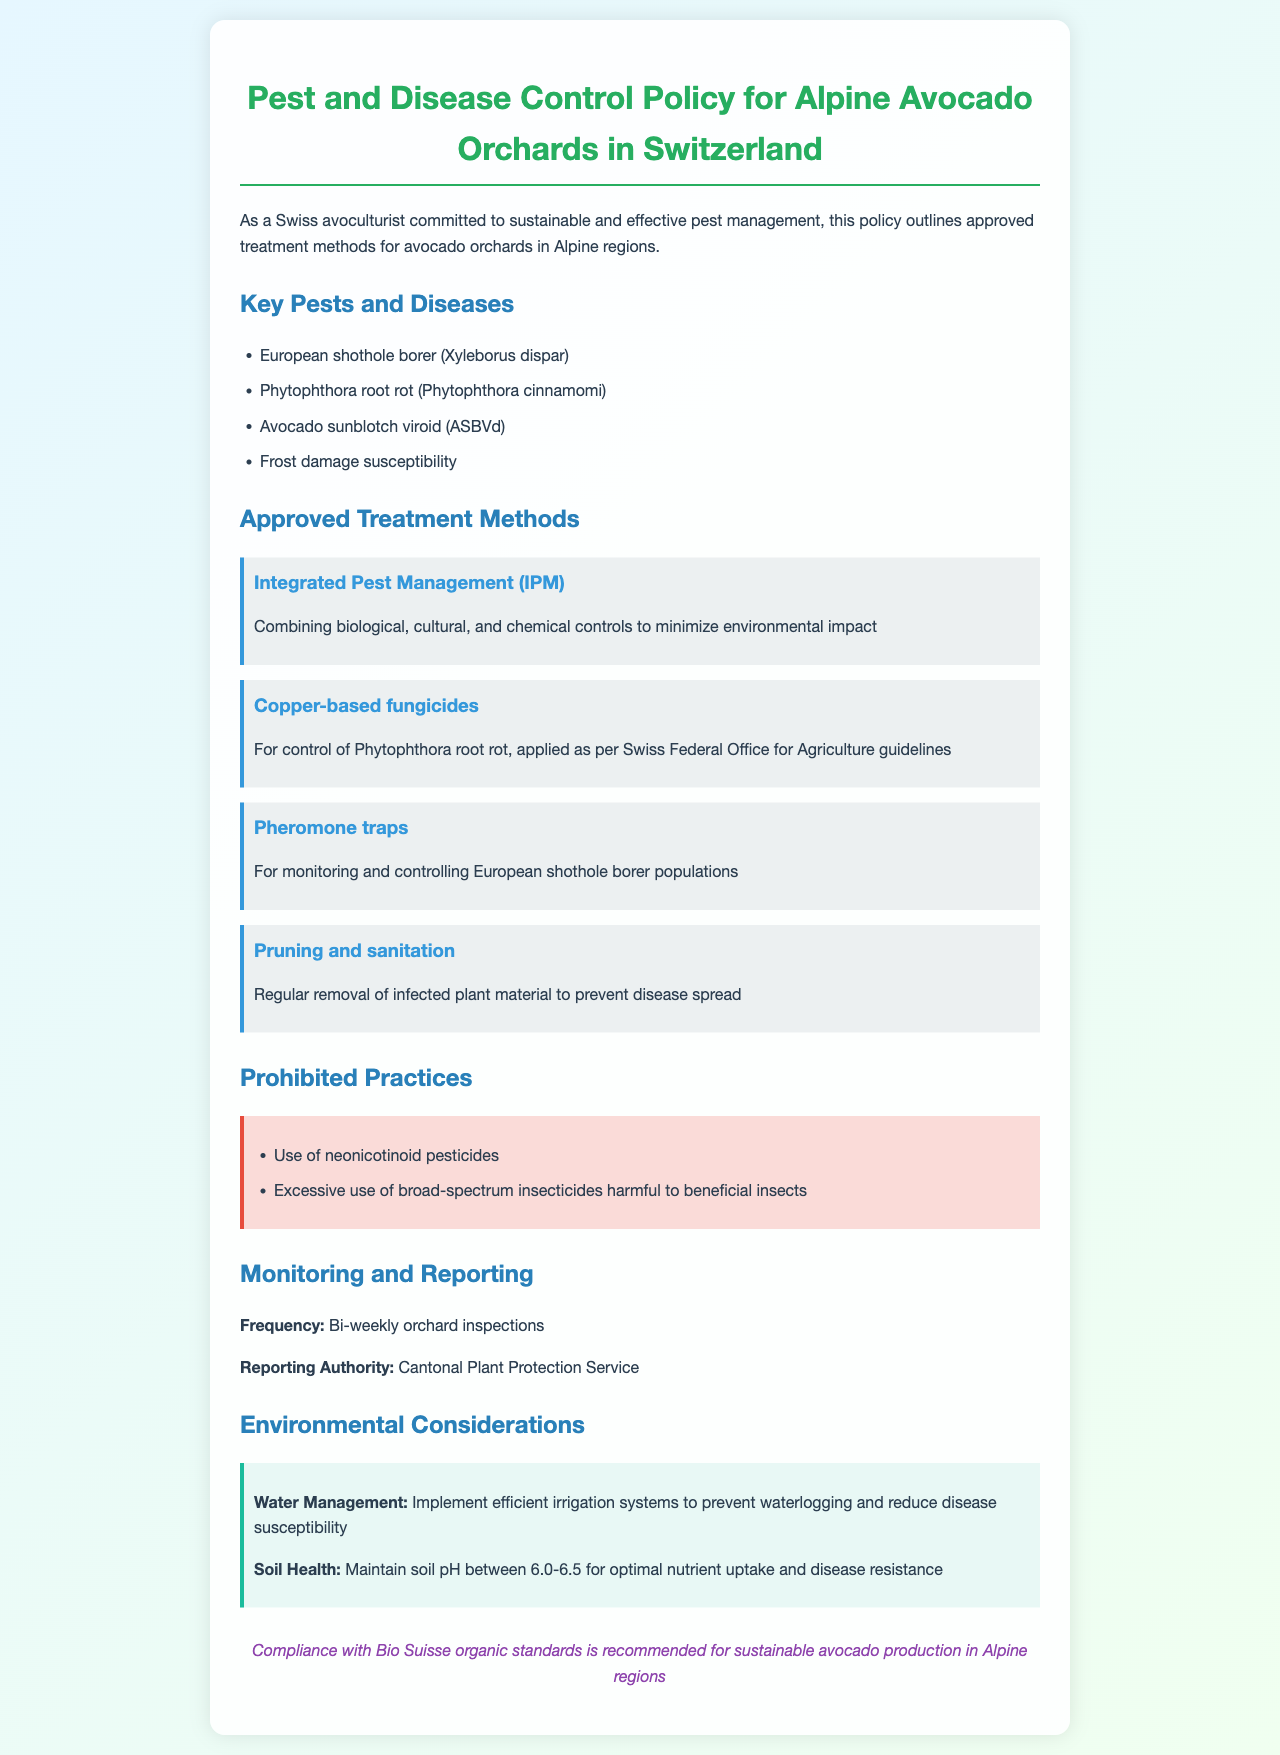what is the title of the document? The title is found in the header section of the document, which introduces the main topic.
Answer: Pest and Disease Control Policy for Alpine Avocado Orchards in Switzerland what is one of the key pests mentioned? The document lists several pests and diseases; referring to the section on key pests is necessary for the answer.
Answer: European shothole borer (Xyleborus dispar) what is the frequency of orchard inspections? The frequency is specified in the Monitoring and Reporting section, detailing the regularity of inspections.
Answer: Bi-weekly which treatment method is used for monitoring shothole borer populations? The document explicitly states specific approved treatment methods, including one specifically aimed at monitoring.
Answer: Pheromone traps what does IPM stand for? The abbreviation IPM is defined in the Approve Treatment Methods section and indicates a specific pest management strategy.
Answer: Integrated Pest Management who is the reporting authority for pest control? The document identifies the authority responsible for reporting, as mentioned under the Monitoring and Reporting section.
Answer: Cantonal Plant Protection Service what is the recommended soil pH range for avocado orchards? The ideal soil condition is highlighted in the Environmental Considerations section, specifying optimal soil pH for health.
Answer: 6.0-6.5 which practices are prohibited? The specific prohibited practices are outlined in a dedicated section, detailing what actions are not allowed for pest control.
Answer: Use of neonicotinoid pesticides what is suggested for sustainable avocado production? The document ends with a recommendation for compliance with recognized standards in avocado production.
Answer: Compliance with Bio Suisse organic standards 